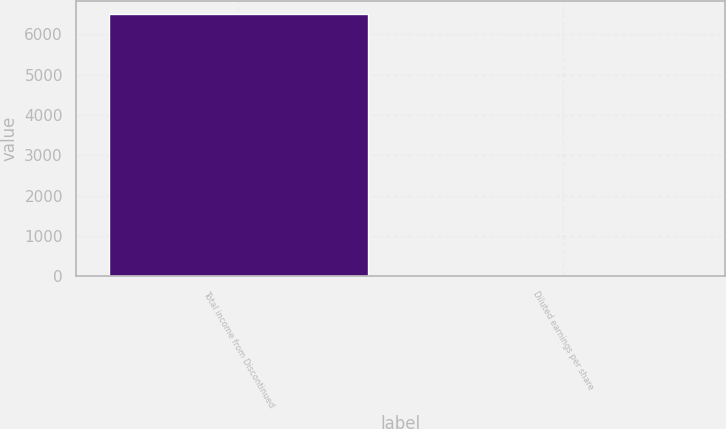<chart> <loc_0><loc_0><loc_500><loc_500><bar_chart><fcel>Total income from Discontinued<fcel>Diluted earnings per share<nl><fcel>6500<fcel>0.02<nl></chart> 